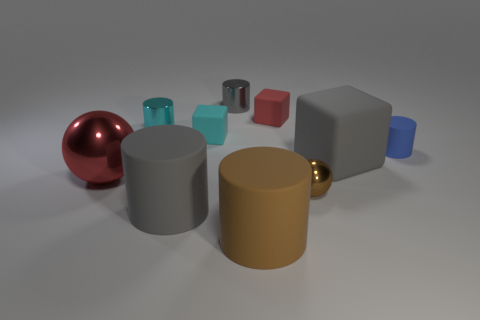There is a red cube that is the same size as the cyan metal object; what material is it?
Your answer should be compact. Rubber. Is there a gray block that has the same material as the small blue thing?
Provide a succinct answer. Yes. There is a large gray matte thing that is left of the gray metallic object that is left of the red thing that is behind the cyan metal thing; what is its shape?
Provide a succinct answer. Cylinder. Is the size of the gray metallic object the same as the gray cylinder in front of the small blue thing?
Provide a short and direct response. No. There is a tiny thing that is both on the left side of the tiny metal ball and on the right side of the gray metallic cylinder; what shape is it?
Provide a succinct answer. Cube. What number of small objects are either gray metallic cylinders or red rubber objects?
Provide a succinct answer. 2. Are there an equal number of big gray things that are in front of the brown shiny sphere and blue objects that are behind the gray matte cylinder?
Your answer should be very brief. Yes. How many other objects are the same color as the tiny matte cylinder?
Keep it short and to the point. 0. Are there the same number of cyan rubber cubes that are left of the tiny red matte cube and small purple things?
Give a very brief answer. No. Is the size of the cyan cylinder the same as the brown cylinder?
Offer a very short reply. No. 